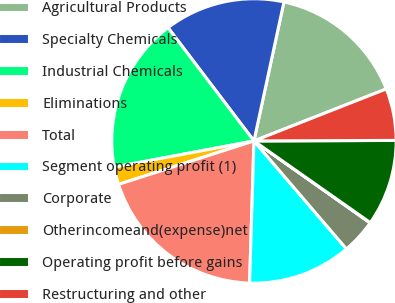Convert chart. <chart><loc_0><loc_0><loc_500><loc_500><pie_chart><fcel>Agricultural Products<fcel>Specialty Chemicals<fcel>Industrial Chemicals<fcel>Eliminations<fcel>Total<fcel>Segment operating profit (1)<fcel>Corporate<fcel>Otherincomeand(expense)net<fcel>Operating profit before gains<fcel>Restructuring and other<nl><fcel>15.66%<fcel>13.71%<fcel>17.62%<fcel>1.99%<fcel>19.57%<fcel>11.76%<fcel>3.95%<fcel>0.04%<fcel>9.8%<fcel>5.9%<nl></chart> 